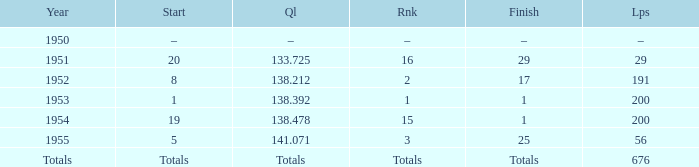What is the start of the race with 676 laps? Totals. 